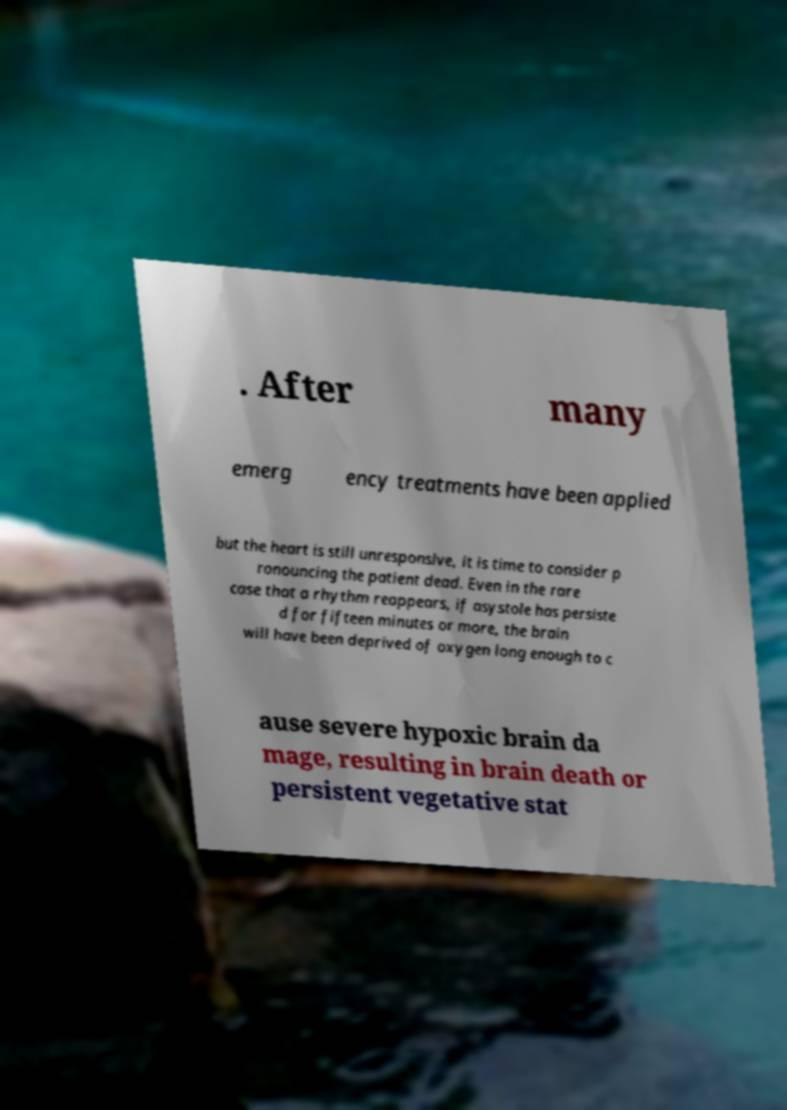Please read and relay the text visible in this image. What does it say? . After many emerg ency treatments have been applied but the heart is still unresponsive, it is time to consider p ronouncing the patient dead. Even in the rare case that a rhythm reappears, if asystole has persiste d for fifteen minutes or more, the brain will have been deprived of oxygen long enough to c ause severe hypoxic brain da mage, resulting in brain death or persistent vegetative stat 